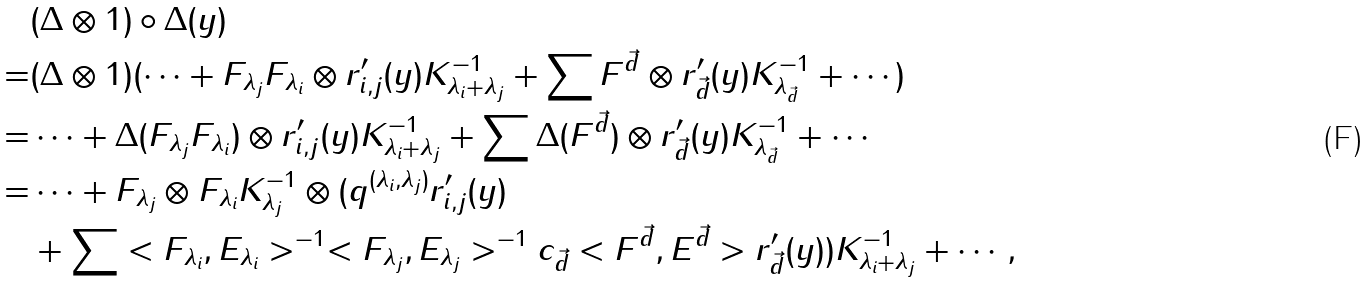<formula> <loc_0><loc_0><loc_500><loc_500>& ( \Delta \otimes 1 ) \circ \Delta ( y ) \\ = & ( \Delta \otimes 1 ) ( \cdots + F _ { \lambda _ { j } } F _ { \lambda _ { i } } \otimes r ^ { \prime } _ { i , j } ( y ) K _ { \lambda _ { i } + \lambda _ { j } } ^ { - 1 } + \sum F ^ { \vec { d } } \otimes r ^ { \prime } _ { \vec { d } } ( y ) K _ { \lambda _ { \vec { d } } } ^ { - 1 } + \cdots ) \\ = & \cdots + \Delta ( F _ { \lambda _ { j } } F _ { \lambda _ { i } } ) \otimes r ^ { \prime } _ { i , j } ( y ) K _ { \lambda _ { i } + \lambda _ { j } } ^ { - 1 } + \sum \Delta ( F ^ { \vec { d } } ) \otimes r ^ { \prime } _ { \vec { d } } ( y ) K _ { \lambda _ { \vec { d } } } ^ { - 1 } + \cdots \\ = & \cdots + F _ { \lambda _ { j } } \otimes F _ { \lambda _ { i } } K _ { \lambda _ { j } } ^ { - 1 } \otimes ( q ^ { ( \lambda _ { i } , \lambda _ { j } ) } r ^ { \prime } _ { i , j } ( y ) \\ & + \sum < F _ { \lambda _ { i } } , E _ { \lambda _ { i } } > ^ { - 1 } < F _ { \lambda _ { j } } , E _ { \lambda _ { j } } > ^ { - 1 } c _ { \vec { d } } < F ^ { \vec { d } } , E ^ { \vec { d } } > r ^ { \prime } _ { \vec { d } } ( y ) ) K _ { \lambda _ { i } + \lambda _ { j } } ^ { - 1 } + \cdots ,</formula> 